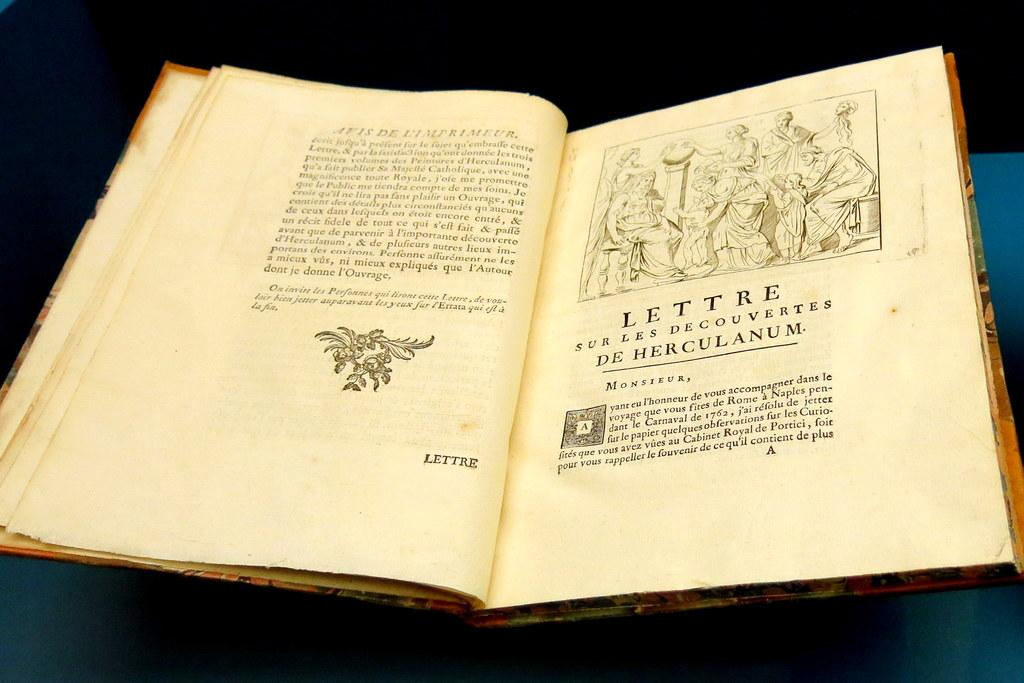<image>
Create a compact narrative representing the image presented. The letter on the open page of the book is written to Monsieur. 